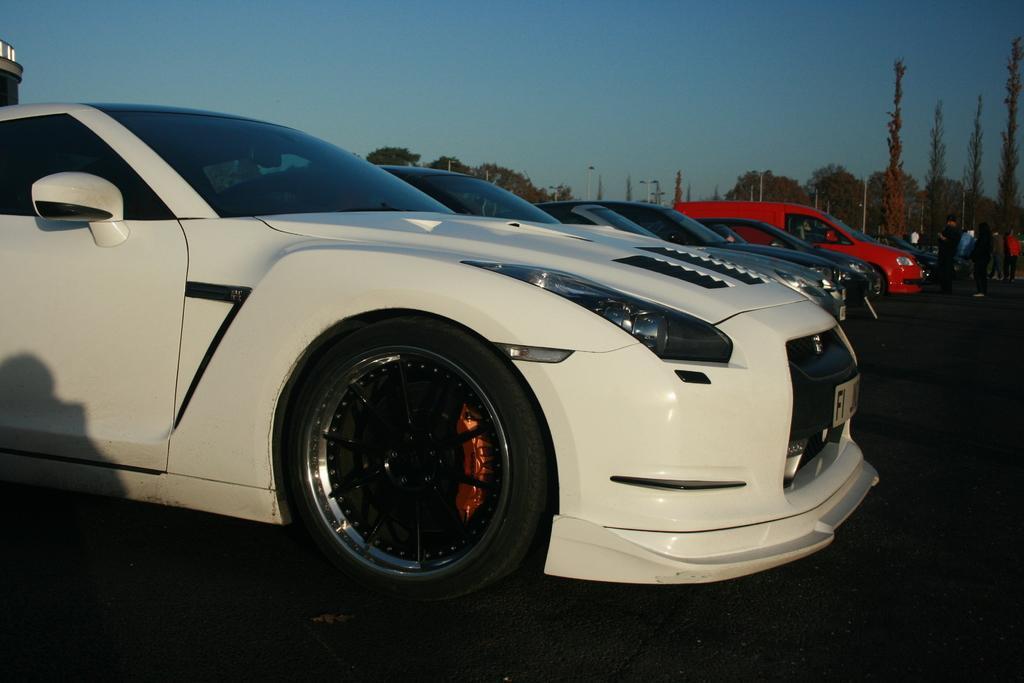Can you describe this image briefly? In this picture we can see there are some vehicles parked on the path and on the right side of the vehicles there are groups of people. Behind the vehicles there are poles, trees and a sky. 